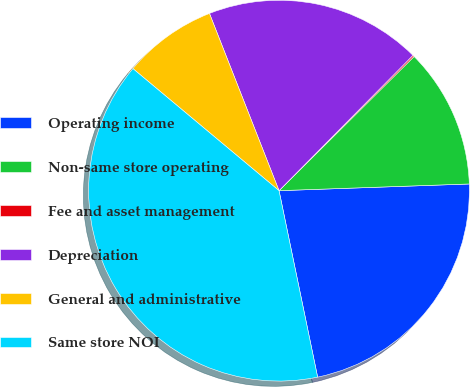Convert chart. <chart><loc_0><loc_0><loc_500><loc_500><pie_chart><fcel>Operating income<fcel>Non-same store operating<fcel>Fee and asset management<fcel>Depreciation<fcel>General and administrative<fcel>Same store NOI<nl><fcel>22.31%<fcel>11.89%<fcel>0.13%<fcel>18.37%<fcel>7.97%<fcel>39.32%<nl></chart> 